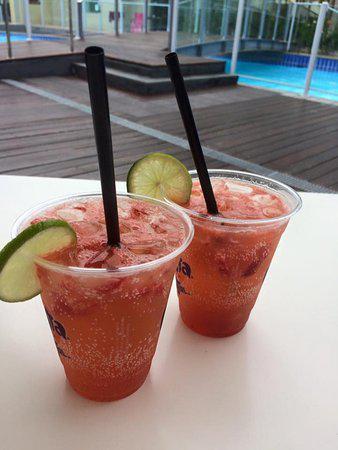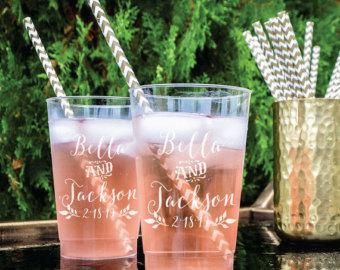The first image is the image on the left, the second image is the image on the right. Examine the images to the left and right. Is the description "There are no more than 2 cups in the left image, and they are all plastic." accurate? Answer yes or no. Yes. The first image is the image on the left, the second image is the image on the right. Assess this claim about the two images: "Some containers are empty.". Correct or not? Answer yes or no. No. 